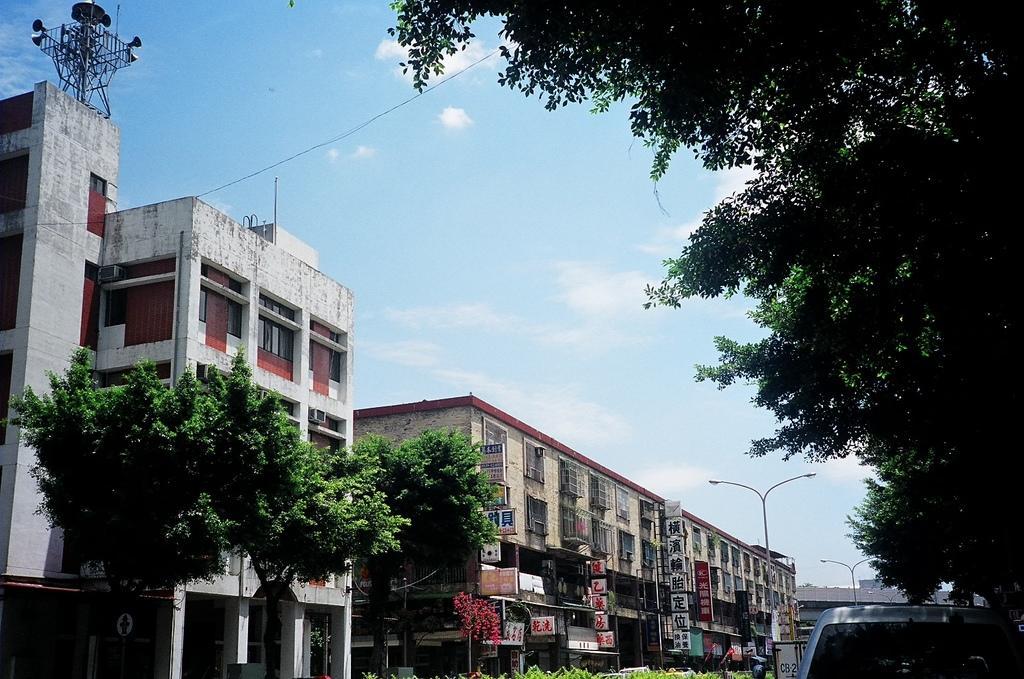Can you describe this image briefly? In this image we can see trees, car, buildings, poles, wire and sky with clouds. 